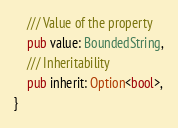<code> <loc_0><loc_0><loc_500><loc_500><_Rust_>	/// Value of the property
	pub value: BoundedString,
	/// Inheritability
	pub inherit: Option<bool>,
}
</code> 